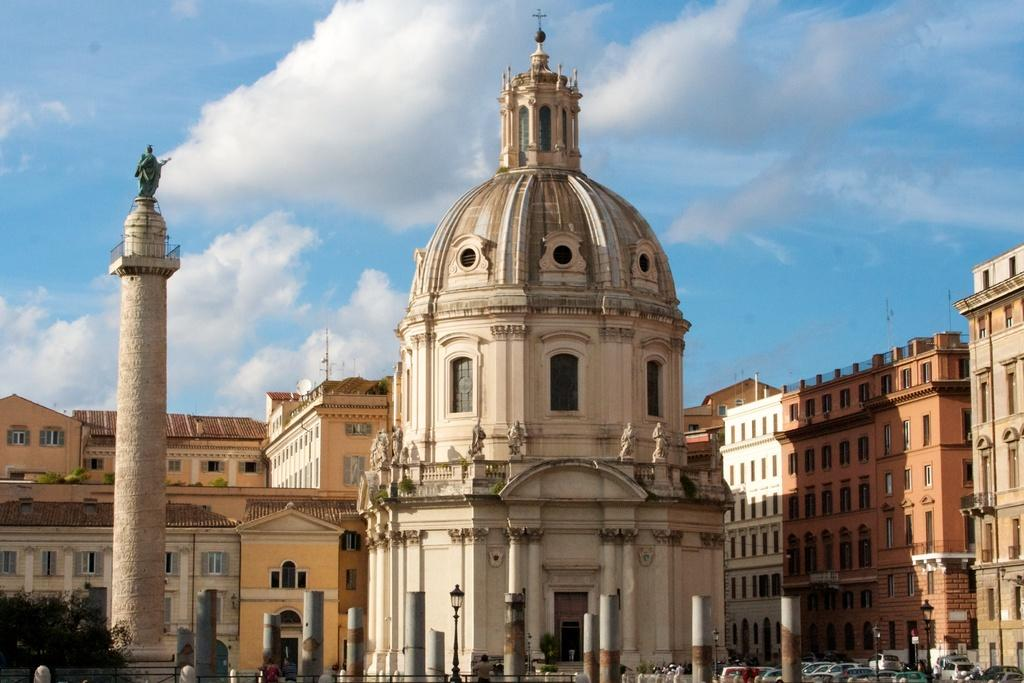What type of structures can be seen in the image? There are buildings in the image. What artistic elements are present in the image? There are sculptures in the image. What type of vegetation is visible in the image? There are trees in the image. What vertical structures can be seen in the image? There are poles in the image. Are there any people present in the image? Yes, there are persons in the image. What mode of transportation can be seen in the image? There are vehicles in the image. What is visible in the background of the image? The sky is visible in the background of the image, and there are clouds in the sky. What type of cushion is being used to attack the sculpture in the image? There is no cushion or attack present in the image; it features buildings, sculptures, trees, poles, persons, vehicles, and a sky with clouds. What caption would best describe the image? The image does not have a caption, as it is a visual representation without accompanying text. 